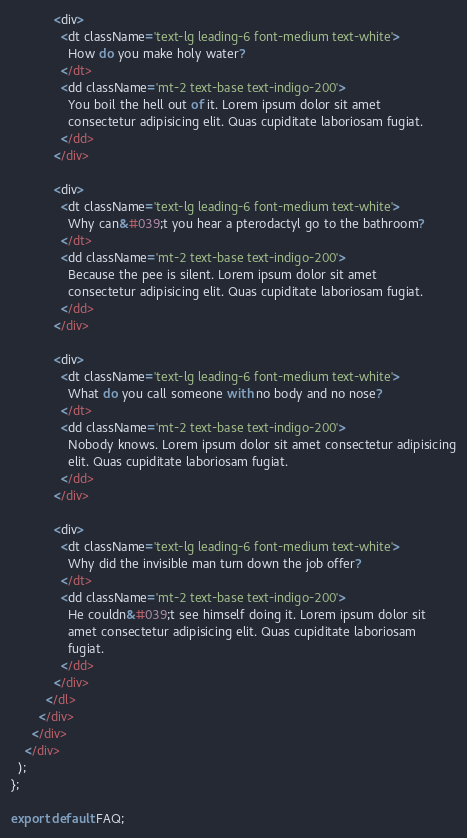Convert code to text. <code><loc_0><loc_0><loc_500><loc_500><_JavaScript_>
            <div>
              <dt className='text-lg leading-6 font-medium text-white'>
                How do you make holy water?
              </dt>
              <dd className='mt-2 text-base text-indigo-200'>
                You boil the hell out of it. Lorem ipsum dolor sit amet
                consectetur adipisicing elit. Quas cupiditate laboriosam fugiat.
              </dd>
            </div>

            <div>
              <dt className='text-lg leading-6 font-medium text-white'>
                Why can&#039;t you hear a pterodactyl go to the bathroom?
              </dt>
              <dd className='mt-2 text-base text-indigo-200'>
                Because the pee is silent. Lorem ipsum dolor sit amet
                consectetur adipisicing elit. Quas cupiditate laboriosam fugiat.
              </dd>
            </div>

            <div>
              <dt className='text-lg leading-6 font-medium text-white'>
                What do you call someone with no body and no nose?
              </dt>
              <dd className='mt-2 text-base text-indigo-200'>
                Nobody knows. Lorem ipsum dolor sit amet consectetur adipisicing
                elit. Quas cupiditate laboriosam fugiat.
              </dd>
            </div>

            <div>
              <dt className='text-lg leading-6 font-medium text-white'>
                Why did the invisible man turn down the job offer?
              </dt>
              <dd className='mt-2 text-base text-indigo-200'>
                He couldn&#039;t see himself doing it. Lorem ipsum dolor sit
                amet consectetur adipisicing elit. Quas cupiditate laboriosam
                fugiat.
              </dd>
            </div>
          </dl>
        </div>
      </div>
    </div>
  );
};

export default FAQ;
</code> 